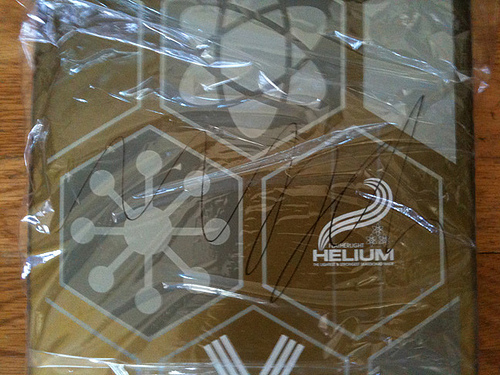<image>
Can you confirm if the scribbling is on the plastic wrap? Yes. Looking at the image, I can see the scribbling is positioned on top of the plastic wrap, with the plastic wrap providing support. 